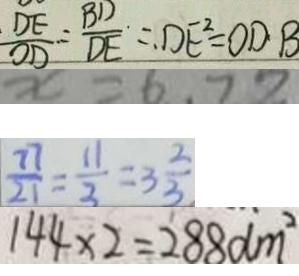Convert formula to latex. <formula><loc_0><loc_0><loc_500><loc_500>\frac { D E } { O D } = \frac { B D } { D E } = D E ^ { 2 } = O D \cdot B 
 x = 6 . 7 8 
 \frac { 7 7 } { 2 1 } = \frac { 1 1 } { 3 } = 3 \frac { 2 } { 3 } 
 1 4 4 \times 2 = 2 8 8 d m ^ { 2 }</formula> 